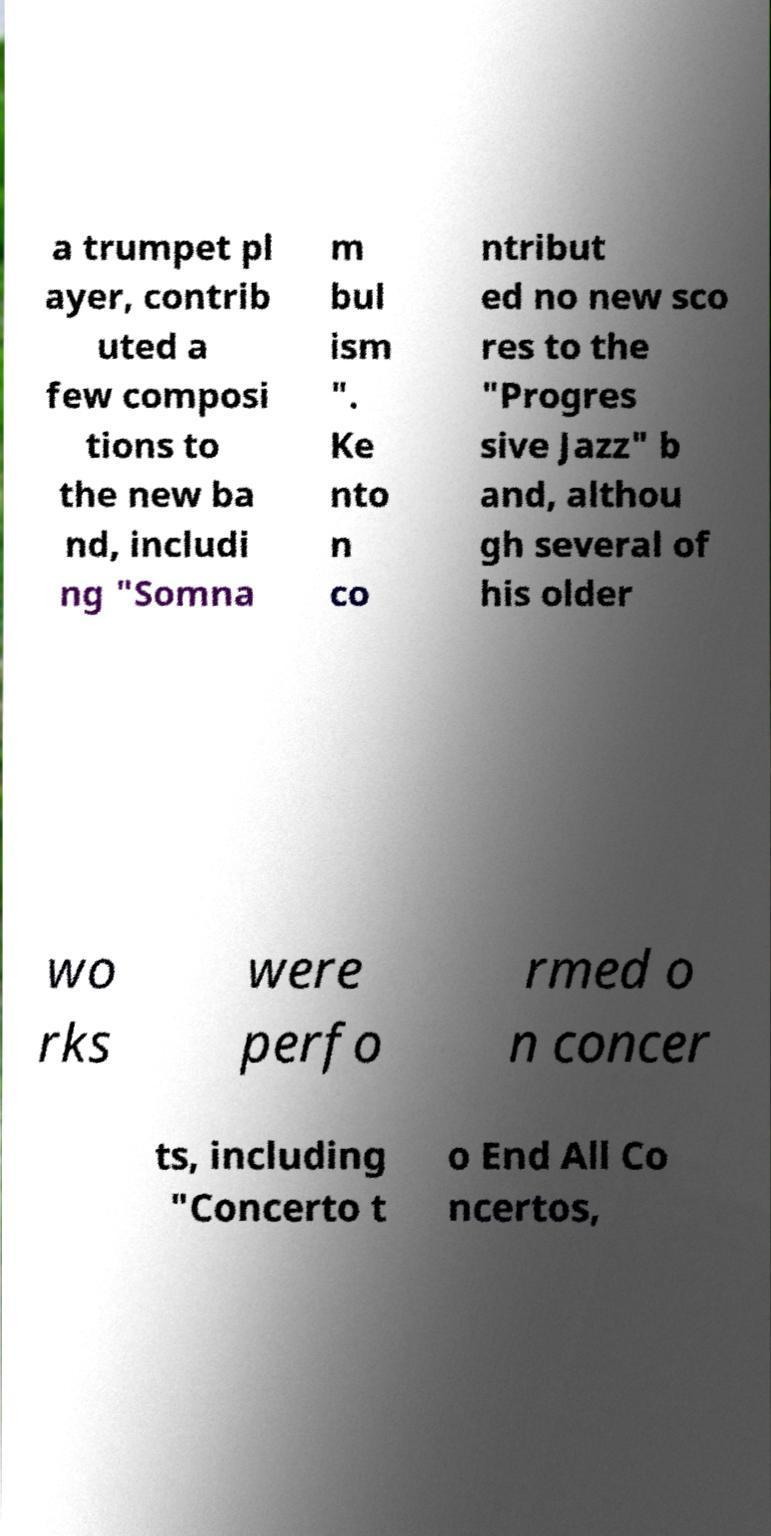Can you read and provide the text displayed in the image?This photo seems to have some interesting text. Can you extract and type it out for me? a trumpet pl ayer, contrib uted a few composi tions to the new ba nd, includi ng "Somna m bul ism ". Ke nto n co ntribut ed no new sco res to the "Progres sive Jazz" b and, althou gh several of his older wo rks were perfo rmed o n concer ts, including "Concerto t o End All Co ncertos, 